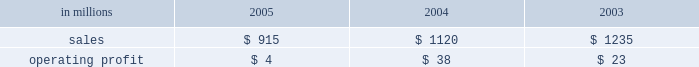Wood products sales in the united states in 2005 of $ 1.6 billion were up 3% ( 3 % ) from $ 1.5 billion in 2004 and 18% ( 18 % ) from $ 1.3 billion in 2003 .
Average price realiza- tions for lumber were up 6% ( 6 % ) and 21% ( 21 % ) in 2005 compared with 2004 and 2003 , respectively .
Lumber sales volumes in 2005 were up 5% ( 5 % ) versus 2004 and 10% ( 10 % ) versus 2003 .
Average sales prices for plywood were down 4% ( 4 % ) from 2004 , but were 15% ( 15 % ) higher than in 2003 .
Plywood sales volumes in 2005 were slightly higher than 2004 and 2003 .
Operating profits in 2005 were 18% ( 18 % ) lower than 2004 , but nearly three times higher than 2003 .
Lower average plywood prices and higher raw material costs more than offset the effects of higher average lumber prices , volume increases and a positive sales mix .
In 2005 , log costs were up 9% ( 9 % ) versus 2004 , negatively im- pacting both plywood and lumber profits .
Lumber and plywood operating costs also reflected substantially higher glue and natural gas costs versus both 2004 and looking forward to the first quarter of 2006 , a con- tinued strong housing market , combined with low prod- uct inventory in the distribution chain , should translate into continued strong lumber and plywood demand .
However , a possible softening of housing starts and higher interest rates later in the year could put down- ward pressure on pricing in the second half of 2006 .
Specialty businesses and other the specialty businesses and other segment in- cludes the operating results of arizona chemical , euro- pean distribution and , prior to its closure in 2003 , our natchez , mississippi chemical cellulose pulp mill .
Also included are certain divested businesses whose results are included in this segment for periods prior to their sale or closure .
This segment 2019s 2005 net sales declined 18% ( 18 % ) and 26% ( 26 % ) from 2004 and 2003 , respectively .
Operating profits in 2005 were down substantially from both 2004 and 2003 .
The decline in sales principally reflects declining contributions from businesses sold or closed .
Operating profits were also affected by higher energy and raw material costs in our chemical business .
Specialty businesses and other in millions 2005 2004 2003 .
Chemicals sales were $ 692 million in 2005 , com- pared with $ 672 million in 2004 and $ 625 million in 2003 .
Although demand was strong for most arizona chemical product lines , operating profits in 2005 were 84% ( 84 % ) and 83% ( 83 % ) lower than in 2004 and 2003 , re- spectively , due to higher energy costs in the u.s. , and higher prices and reduced availability for crude tall oil ( cto ) .
In the united states , energy costs increased 41% ( 41 % ) compared to 2004 due to higher natural gas prices and supply interruption costs .
Cto prices increased 26% ( 26 % ) compared to 2004 , as certain energy users turned to cto as a substitute fuel for high-cost alternative energy sources such as natural gas and fuel oil .
European cto receipts decreased 30% ( 30 % ) compared to 2004 due to lower yields following the finnish paper industry strike and a swedish storm that limited cto throughput and corre- sponding sales volumes .
Other businesses in this operating segment include operations that have been sold , closed , or are held for sale , principally the european distribution business , the oil and gas and mineral royalty business , decorative products , retail packaging , and the natchez chemical cellulose pulp mill .
Sales for these businesses were ap- proximately $ 223 million in 2005 ( mainly european distribution and decorative products ) compared with $ 448 million in 2004 ( mainly european distribution and decorative products ) , and $ 610 million in 2003 .
Liquidity and capital resources overview a major factor in international paper 2019s liquidity and capital resource planning is its generation of operat- ing cash flow , which is highly sensitive to changes in the pricing and demand for our major products .
While changes in key cash operating costs , such as energy and raw material costs , do have an effect on operating cash generation , we believe that our strong focus on cost controls has improved our cash flow generation over an operating cycle .
As a result , we believe that we are well positioned for improvements in operating cash flow should prices and worldwide economic conditions im- prove in the future .
As part of our continuing focus on improving our return on investment , we have focused our capital spending on improving our key platform businesses in north america and in geographic areas with strong growth opportunities .
Spending levels have been kept below the level of depreciation and amortization charges for each of the last three years , and we anticipate con- tinuing this approach in 2006 .
With the low interest rate environment in 2005 , financing activities have focused largely on the repay- ment or refinancing of higher coupon debt , resulting in a net reduction in debt of approximately $ 1.7 billion in 2005 .
We plan to continue this program , with addi- tional reductions anticipated as our previously an- nounced transformation plan progresses in 2006 .
Our liquidity position continues to be strong , with approx- imately $ 3.2 billion of committed liquidity to cover fu- ture short-term cash flow requirements not met by operating cash flows. .
What percentage of specialty businesses sales where due to chemicals sales in 2005? 
Computations: (692 / 915)
Answer: 0.75628. 